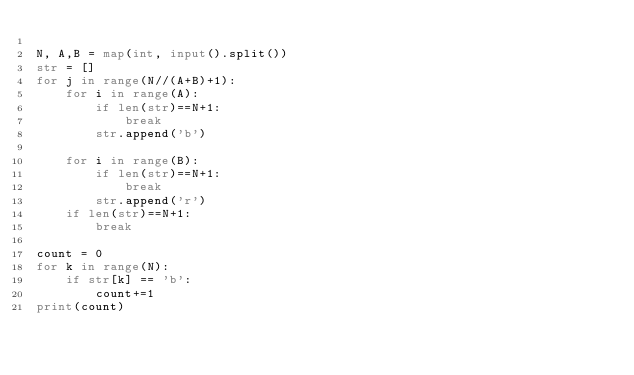Convert code to text. <code><loc_0><loc_0><loc_500><loc_500><_Python_>
N, A,B = map(int, input().split())
str = []
for j in range(N//(A+B)+1):
    for i in range(A):
        if len(str)==N+1:
            break
        str.append('b')

    for i in range(B):
        if len(str)==N+1:
            break
        str.append('r')
    if len(str)==N+1:
        break

count = 0
for k in range(N):
    if str[k] == 'b':
        count+=1
print(count)
</code> 